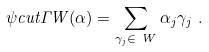Convert formula to latex. <formula><loc_0><loc_0><loc_500><loc_500>\psi c u t { \Gamma } { W } ( \alpha ) = \sum _ { \gamma _ { j } \in \ W } \alpha _ { j } \gamma _ { j } \ .</formula> 